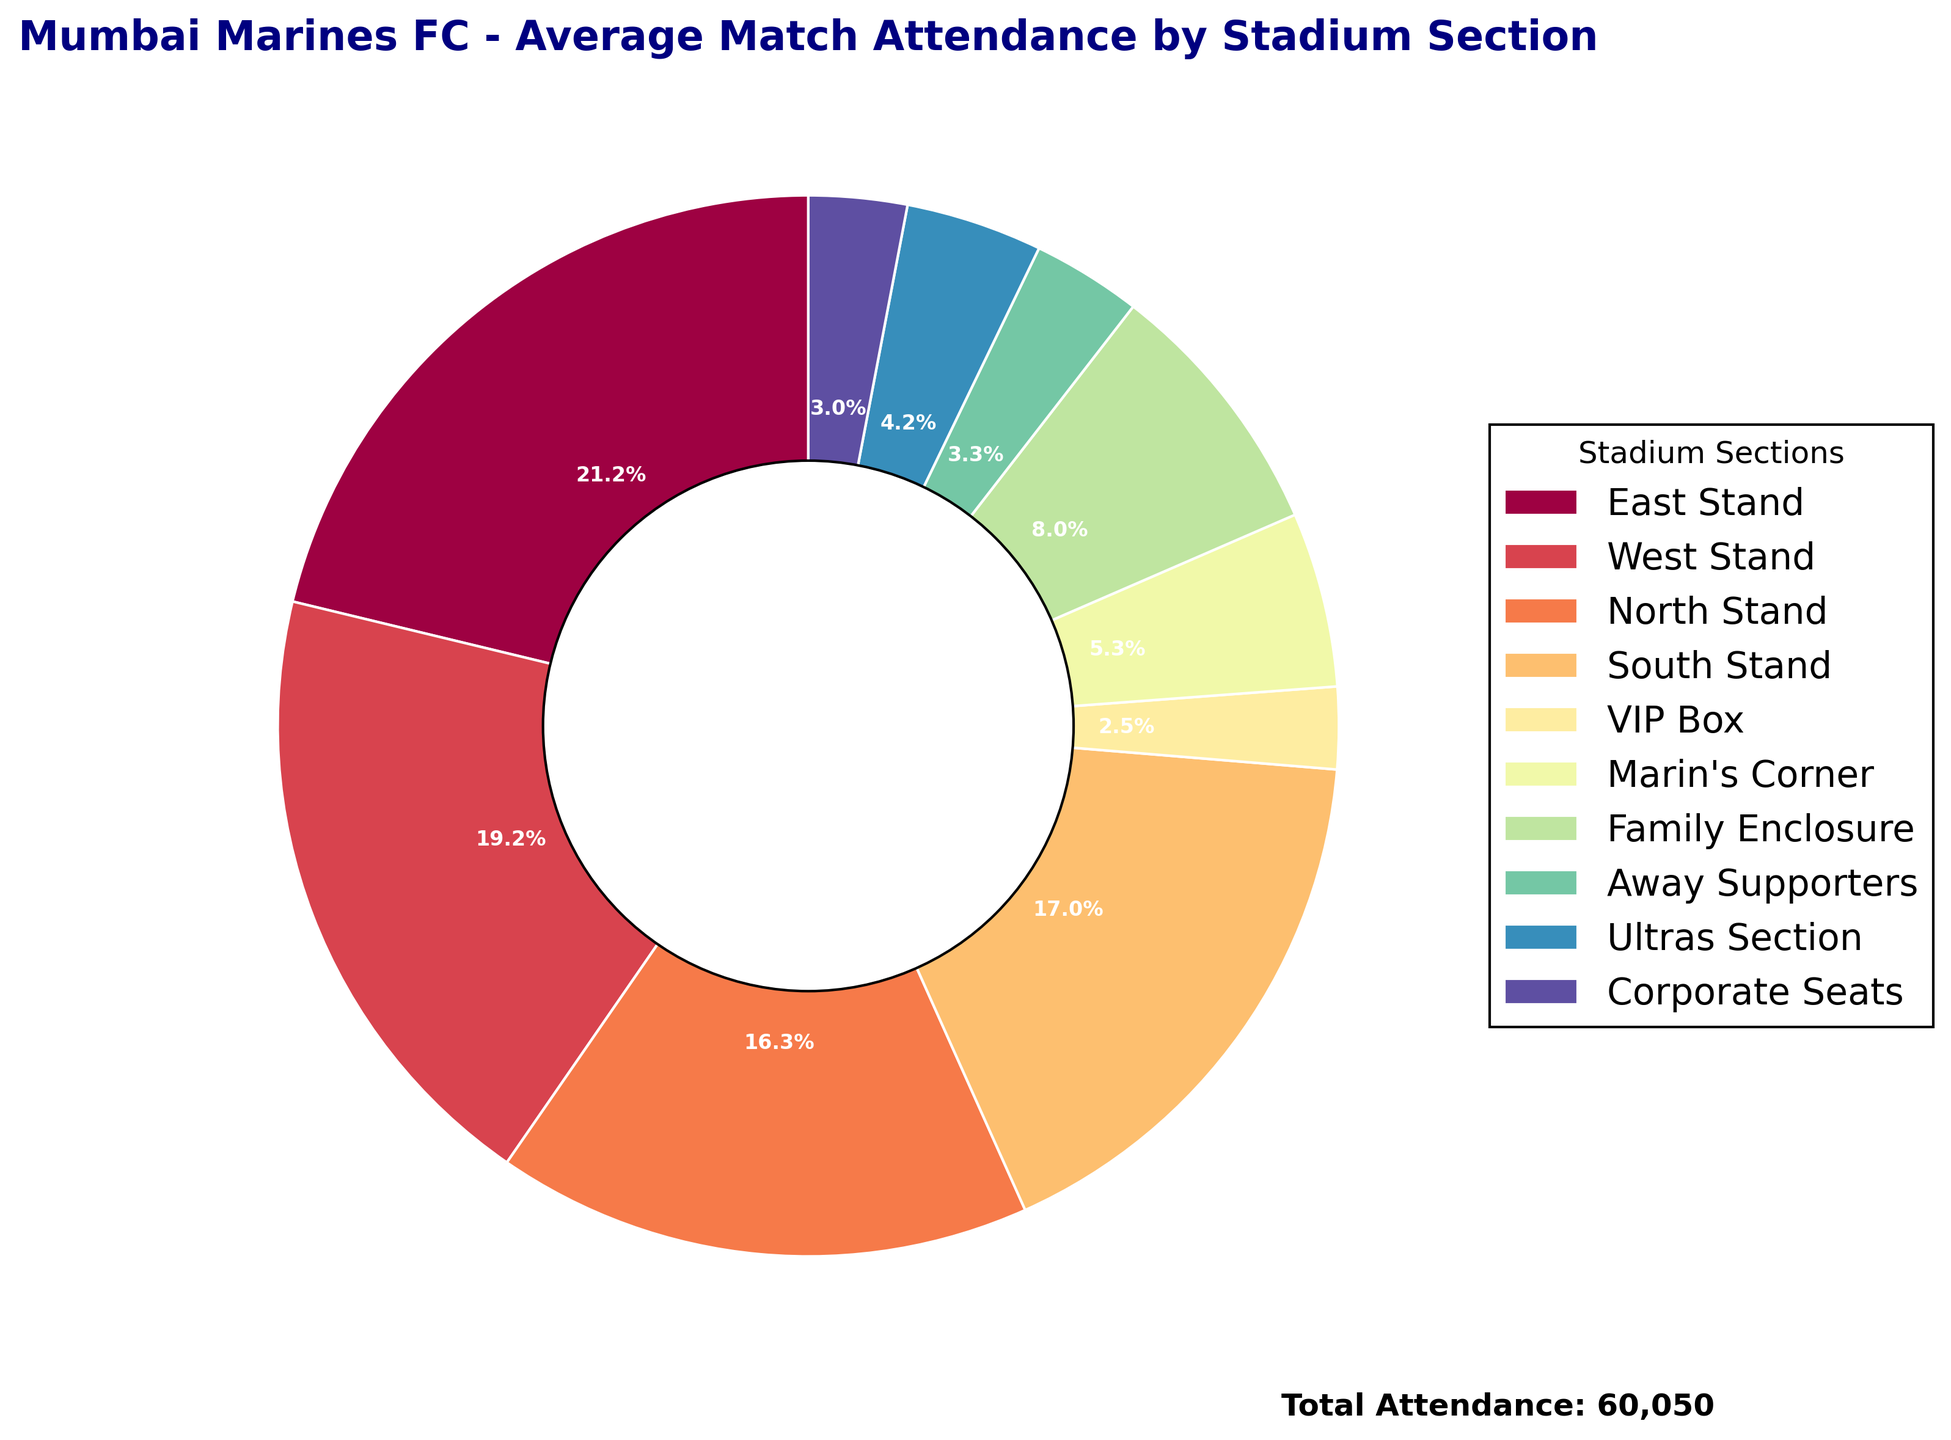Which section has the lowest average match attendance? Looking at the sections and their corresponding percentages, the VIP Box is labeled with the lowest percentage value, indicating it has the lowest average attendance.
Answer: VIP Box Which section has the highest average attendance? The East Stand, with its label showing the highest percentage out of all sections, represents the one with the highest average match attendance.
Answer: East Stand How many total sections are there? The figure shows various sections labeled around the pie chart. Counting these labels gives the total number of sections.
Answer: 10 What is the combined attendance of the North Stand and South Stand? The North Stand has 9,800 and the South Stand has 10,200. Adding these together 9,800 + 10,200 = 20,000
Answer: 20,000 Which section has more attendance: the Family Enclosure or the Marin’s Corner? The Family Enclosure has 4,800, while Marin’s Corner has 3,200 according to the labels in the pie chart. 4,800 (Family Enclosure) > 3,200 (Marin’s Corner)
Answer: Family Enclosure By how much does the attendance of the West Stand exceed the Family Enclosure? The West Stand has 11,500, and the Family Enclosure has 4,800. Subtracting these figures, 11,500 - 4,800 = 6,700
Answer: 6,700 Which section contributes more to attendance: the Ultras Section or Corporate Seats? The Ultras Section has 2,500, and Corporate Seats have 1,800. Comparing these, 2,500 > 1,800
Answer: Ultras Section What percentage of the total attendance does the Away Supporters section represent? The total attendance is the sum of all attendances: 12,750 + 11,500 + 9,800 + 10,200 + 1,500 + 3,200 + 4,800 + 2,000 + 2,500 + 1,800 = 60,050. The Away Supporters' attendance is 2,000. To find the percentage: (2,000 / 60,050) * 100 ≈ 3.3%
Answer: 3.3% Which section has the third largest average attendance? Sorting the attendances, we find: East Stand (12,750), West Stand (11,500), and the South Stand (10,200) is third.
Answer: South Stand If total attendance were to increase by 10%, how many attendees would there be in the North Stand? The North Stand has 9,800 attendees. A 10% increase is 9,800 * 0.10 = 980. Adding this to the original gives: 9,800 + 980 = 10,780
Answer: 10,780 